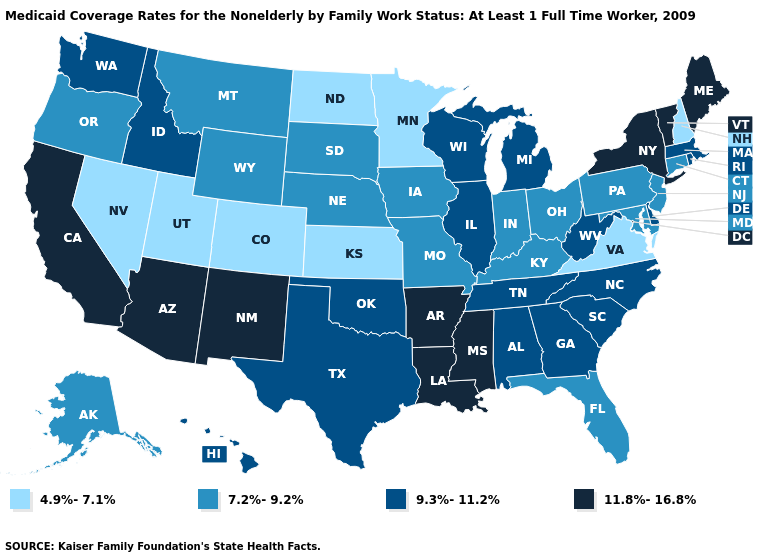Does Texas have the same value as Nevada?
Be succinct. No. Name the states that have a value in the range 4.9%-7.1%?
Write a very short answer. Colorado, Kansas, Minnesota, Nevada, New Hampshire, North Dakota, Utah, Virginia. What is the lowest value in the West?
Short answer required. 4.9%-7.1%. What is the highest value in the MidWest ?
Be succinct. 9.3%-11.2%. Among the states that border Vermont , which have the highest value?
Give a very brief answer. New York. How many symbols are there in the legend?
Quick response, please. 4. Which states have the lowest value in the USA?
Keep it brief. Colorado, Kansas, Minnesota, Nevada, New Hampshire, North Dakota, Utah, Virginia. What is the value of New Jersey?
Write a very short answer. 7.2%-9.2%. Name the states that have a value in the range 4.9%-7.1%?
Concise answer only. Colorado, Kansas, Minnesota, Nevada, New Hampshire, North Dakota, Utah, Virginia. What is the lowest value in the USA?
Concise answer only. 4.9%-7.1%. Name the states that have a value in the range 11.8%-16.8%?
Quick response, please. Arizona, Arkansas, California, Louisiana, Maine, Mississippi, New Mexico, New York, Vermont. Name the states that have a value in the range 11.8%-16.8%?
Concise answer only. Arizona, Arkansas, California, Louisiana, Maine, Mississippi, New Mexico, New York, Vermont. What is the highest value in the USA?
Be succinct. 11.8%-16.8%. What is the value of New Hampshire?
Keep it brief. 4.9%-7.1%. Among the states that border Mississippi , which have the highest value?
Short answer required. Arkansas, Louisiana. 